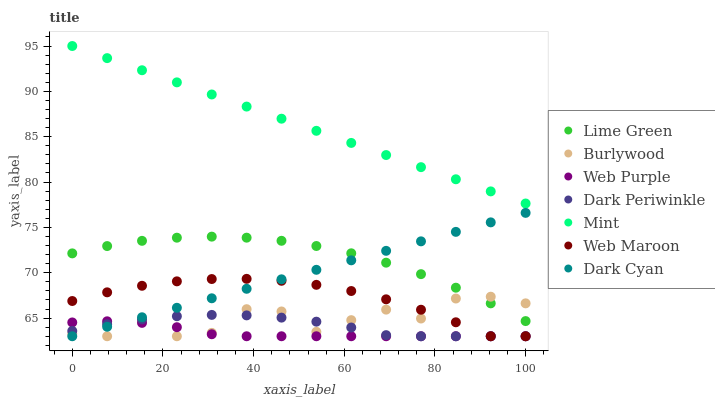Does Web Purple have the minimum area under the curve?
Answer yes or no. Yes. Does Mint have the maximum area under the curve?
Answer yes or no. Yes. Does Lime Green have the minimum area under the curve?
Answer yes or no. No. Does Lime Green have the maximum area under the curve?
Answer yes or no. No. Is Dark Cyan the smoothest?
Answer yes or no. Yes. Is Burlywood the roughest?
Answer yes or no. Yes. Is Lime Green the smoothest?
Answer yes or no. No. Is Lime Green the roughest?
Answer yes or no. No. Does Burlywood have the lowest value?
Answer yes or no. Yes. Does Lime Green have the lowest value?
Answer yes or no. No. Does Mint have the highest value?
Answer yes or no. Yes. Does Lime Green have the highest value?
Answer yes or no. No. Is Dark Periwinkle less than Mint?
Answer yes or no. Yes. Is Mint greater than Burlywood?
Answer yes or no. Yes. Does Burlywood intersect Dark Cyan?
Answer yes or no. Yes. Is Burlywood less than Dark Cyan?
Answer yes or no. No. Is Burlywood greater than Dark Cyan?
Answer yes or no. No. Does Dark Periwinkle intersect Mint?
Answer yes or no. No. 